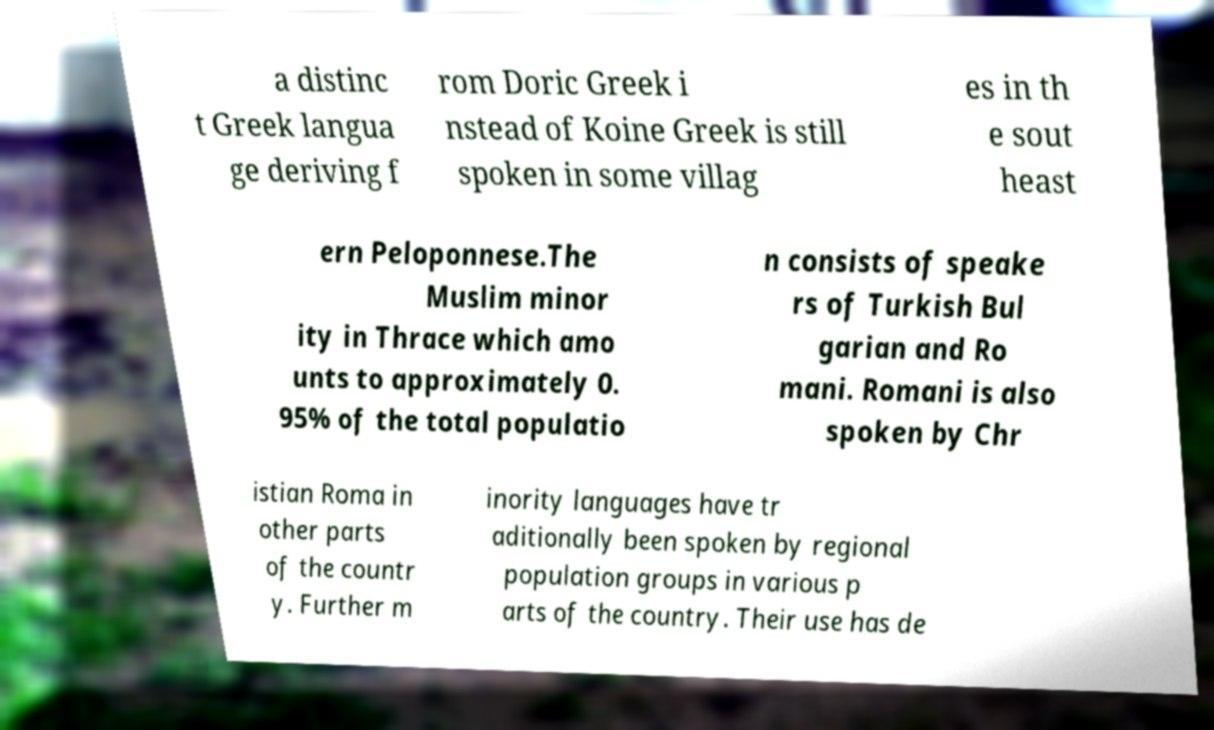Please identify and transcribe the text found in this image. a distinc t Greek langua ge deriving f rom Doric Greek i nstead of Koine Greek is still spoken in some villag es in th e sout heast ern Peloponnese.The Muslim minor ity in Thrace which amo unts to approximately 0. 95% of the total populatio n consists of speake rs of Turkish Bul garian and Ro mani. Romani is also spoken by Chr istian Roma in other parts of the countr y. Further m inority languages have tr aditionally been spoken by regional population groups in various p arts of the country. Their use has de 